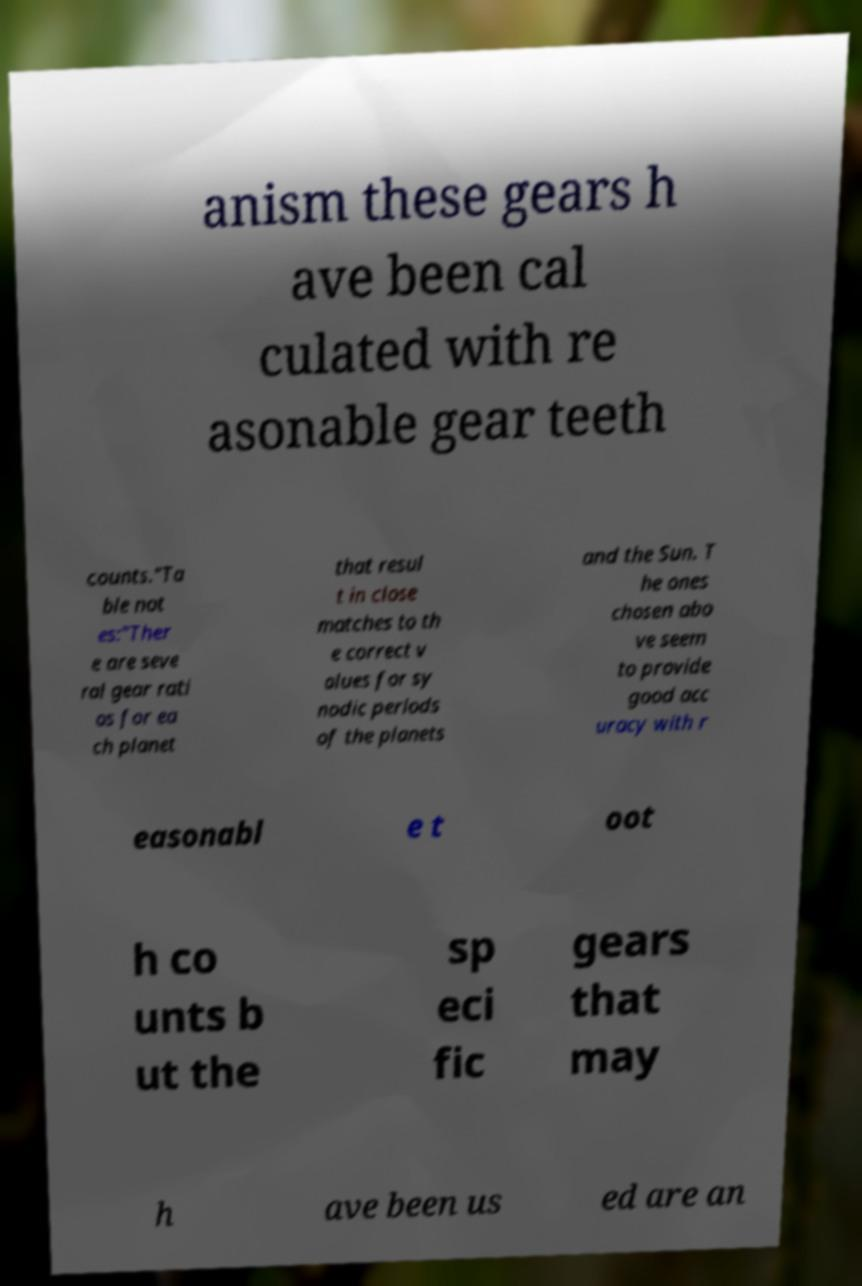Can you read and provide the text displayed in the image?This photo seems to have some interesting text. Can you extract and type it out for me? anism these gears h ave been cal culated with re asonable gear teeth counts."Ta ble not es:"Ther e are seve ral gear rati os for ea ch planet that resul t in close matches to th e correct v alues for sy nodic periods of the planets and the Sun. T he ones chosen abo ve seem to provide good acc uracy with r easonabl e t oot h co unts b ut the sp eci fic gears that may h ave been us ed are an 